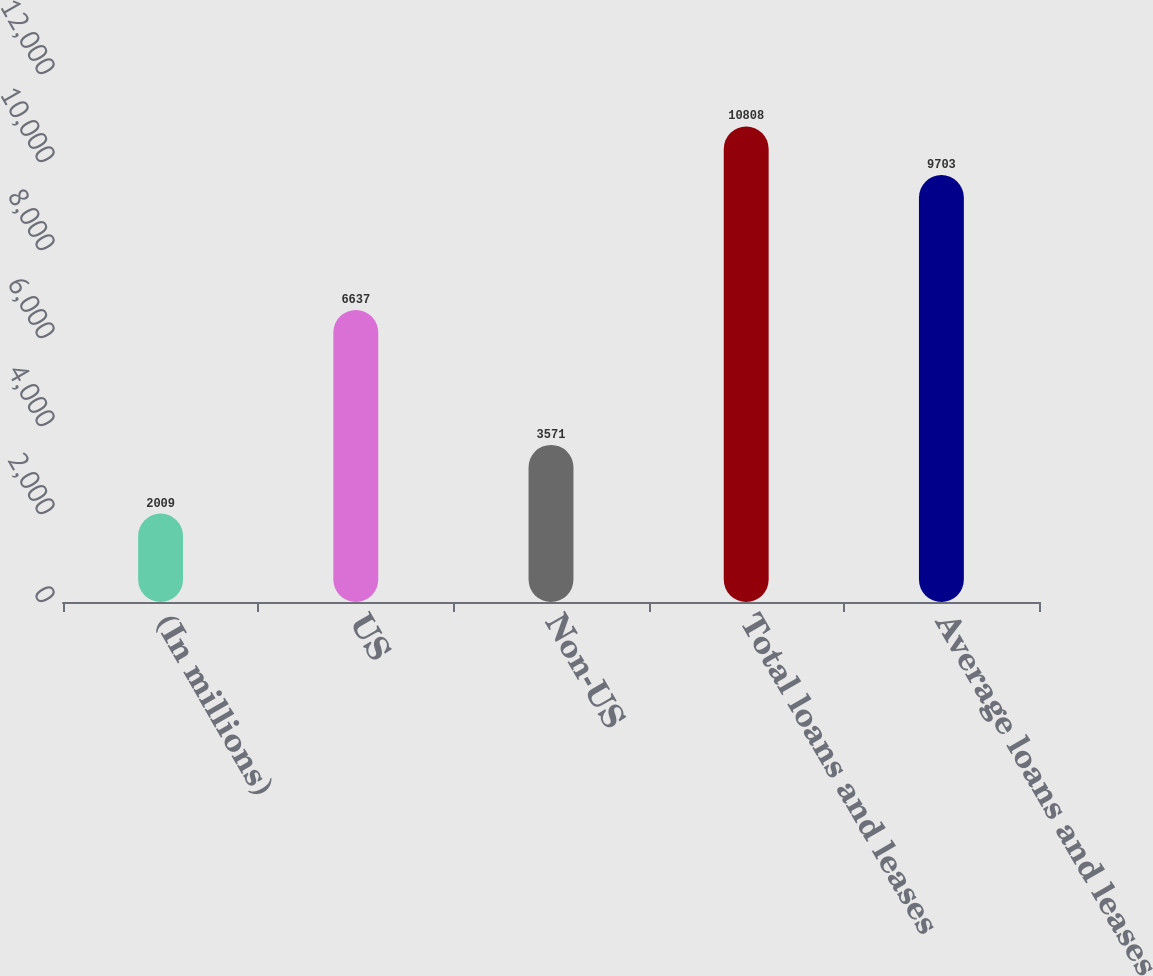Convert chart to OTSL. <chart><loc_0><loc_0><loc_500><loc_500><bar_chart><fcel>(In millions)<fcel>US<fcel>Non-US<fcel>Total loans and leases<fcel>Average loans and leases<nl><fcel>2009<fcel>6637<fcel>3571<fcel>10808<fcel>9703<nl></chart> 